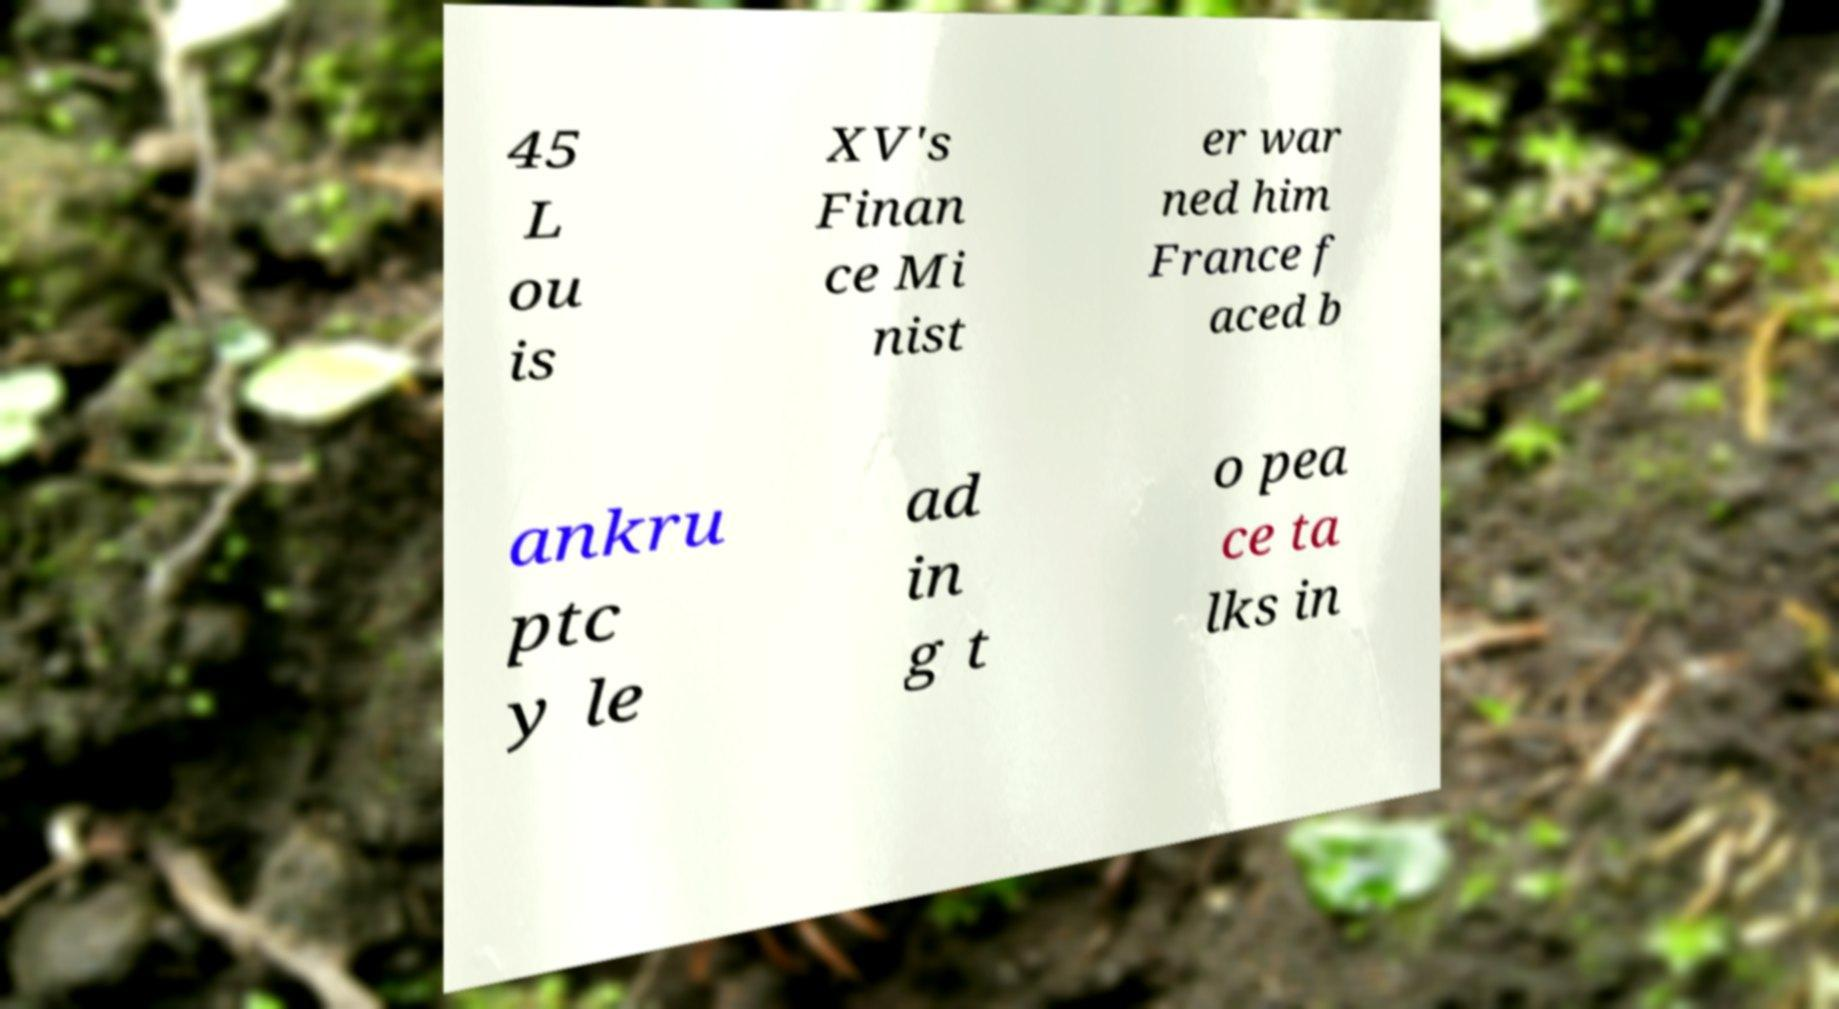Please identify and transcribe the text found in this image. 45 L ou is XV's Finan ce Mi nist er war ned him France f aced b ankru ptc y le ad in g t o pea ce ta lks in 